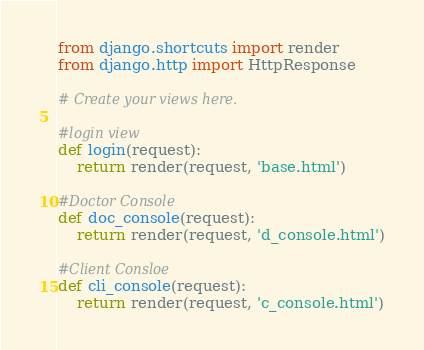<code> <loc_0><loc_0><loc_500><loc_500><_Python_>from django.shortcuts import render
from django.http import HttpResponse

# Create your views here.

#login view
def login(request):
    return render(request, 'base.html')

#Doctor Console
def doc_console(request):
    return render(request, 'd_console.html')

#Client Consloe
def cli_console(request):
    return render(request, 'c_console.html')</code> 